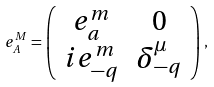Convert formula to latex. <formula><loc_0><loc_0><loc_500><loc_500>e ^ { M } _ { A } = \left ( \begin{array} { c c } e ^ { m } _ { a } & 0 \\ i e _ { - q } ^ { m } & \delta _ { - q } ^ { \mu } \end{array} \right ) ,</formula> 